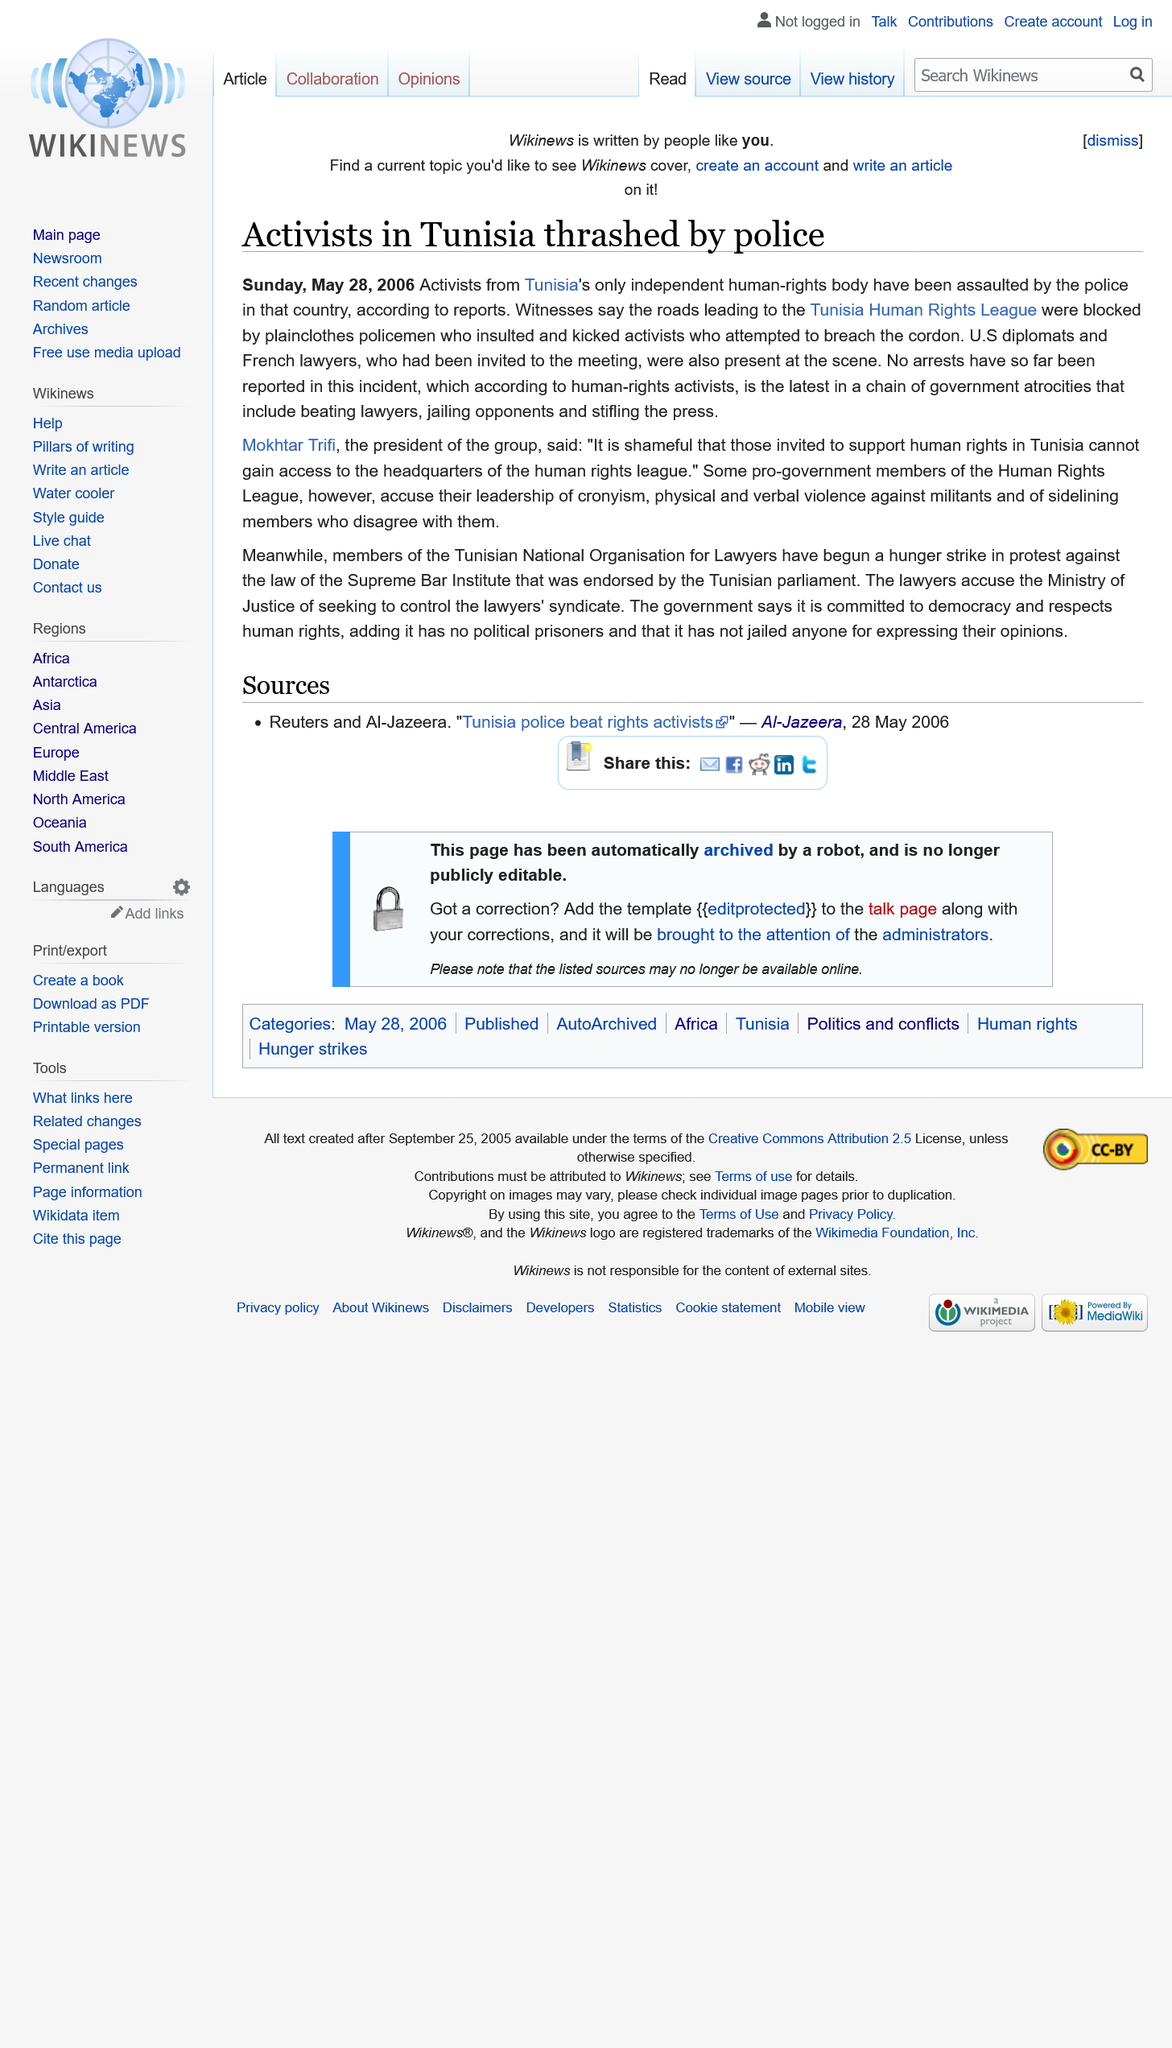Give some essential details in this illustration. As of yet, no arrests have been reported in connection to the incident. Mokhtar Trifi is the president of Tunisia's only independent human-rights body, and he is the one who holds this position. Witnesses report that the roads leading to the Tunisia Human Rights League were blocked by plain clothes policemen. 